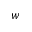Convert formula to latex. <formula><loc_0><loc_0><loc_500><loc_500>w</formula> 